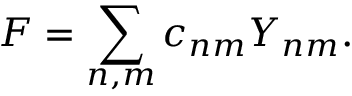<formula> <loc_0><loc_0><loc_500><loc_500>F = \sum _ { n , m } c _ { n m } Y _ { n m } .</formula> 